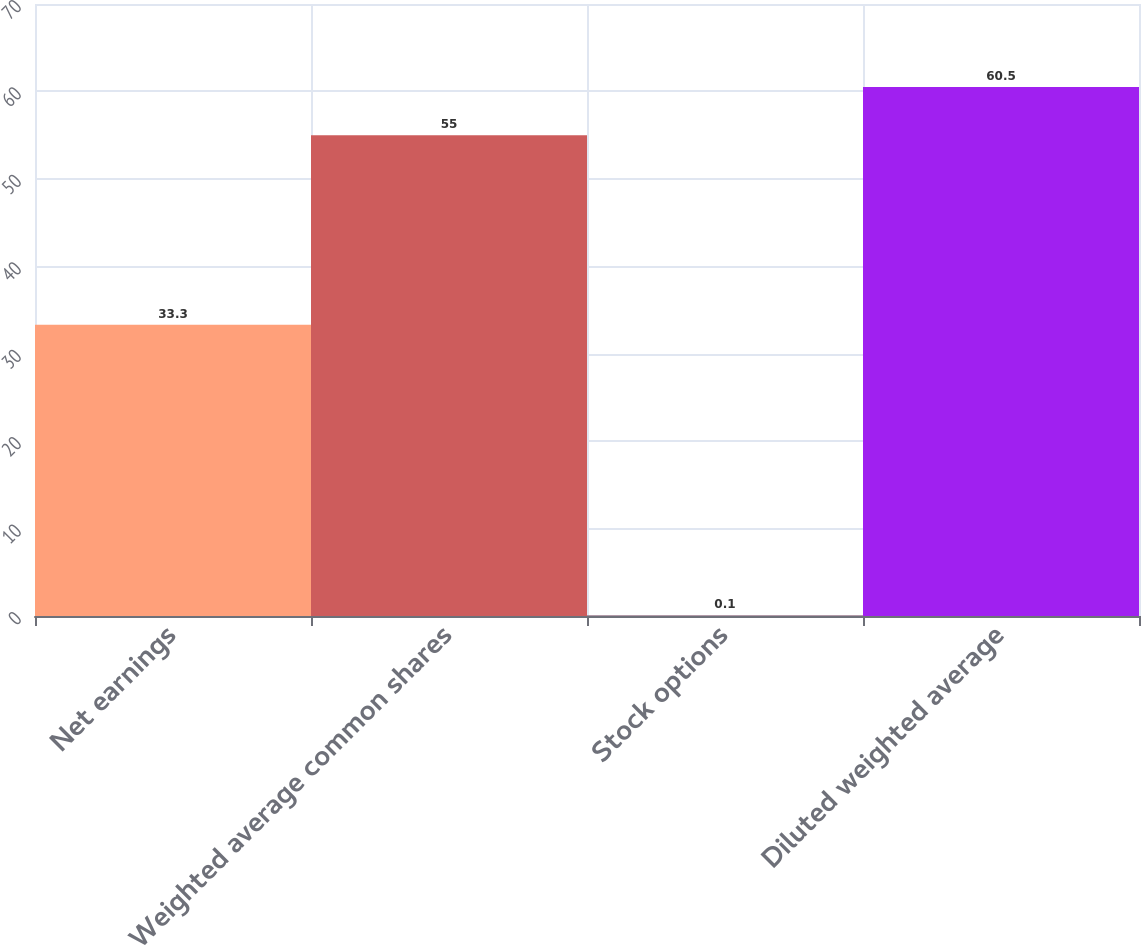<chart> <loc_0><loc_0><loc_500><loc_500><bar_chart><fcel>Net earnings<fcel>Weighted average common shares<fcel>Stock options<fcel>Diluted weighted average<nl><fcel>33.3<fcel>55<fcel>0.1<fcel>60.5<nl></chart> 